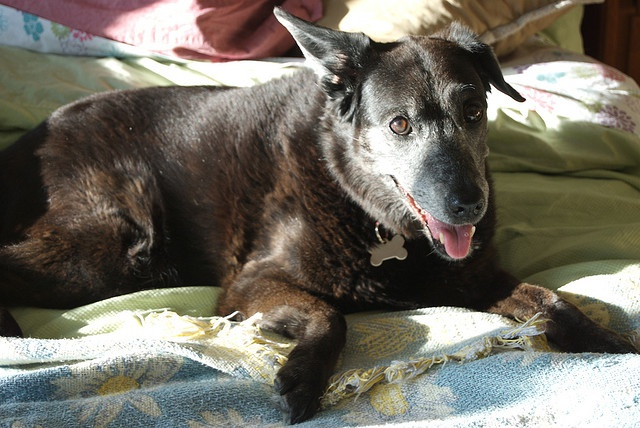Describe the objects in this image and their specific colors. I can see bed in brown, white, gray, darkgreen, and darkgray tones and dog in brown, black, gray, and darkgray tones in this image. 